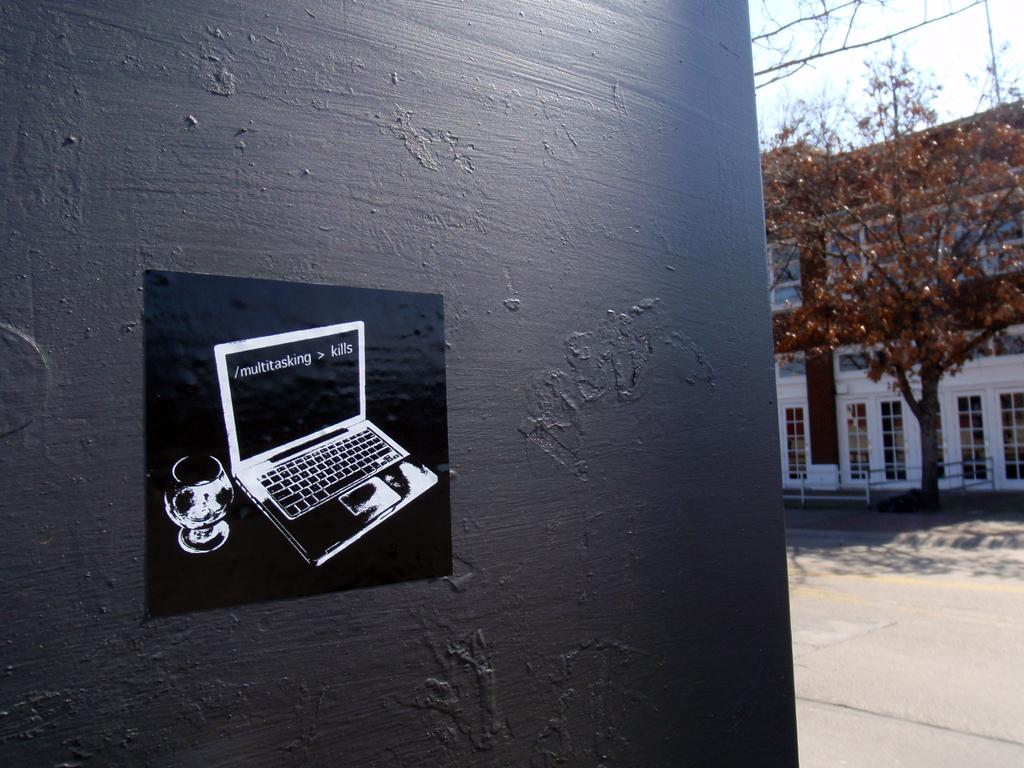<image>
Summarize the visual content of the image. A laptop image on a wall where the directional for multitasking is on the screen. 